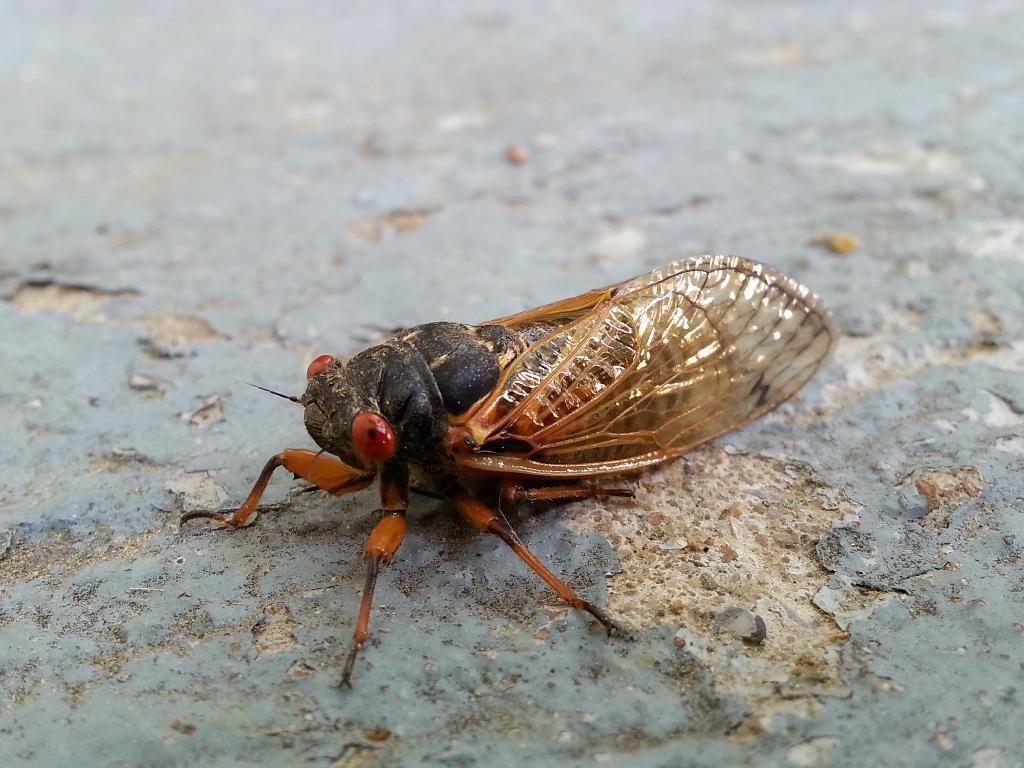Describe this image in one or two sentences. In this image we can see an insect. In the background of the image there is a floor. 